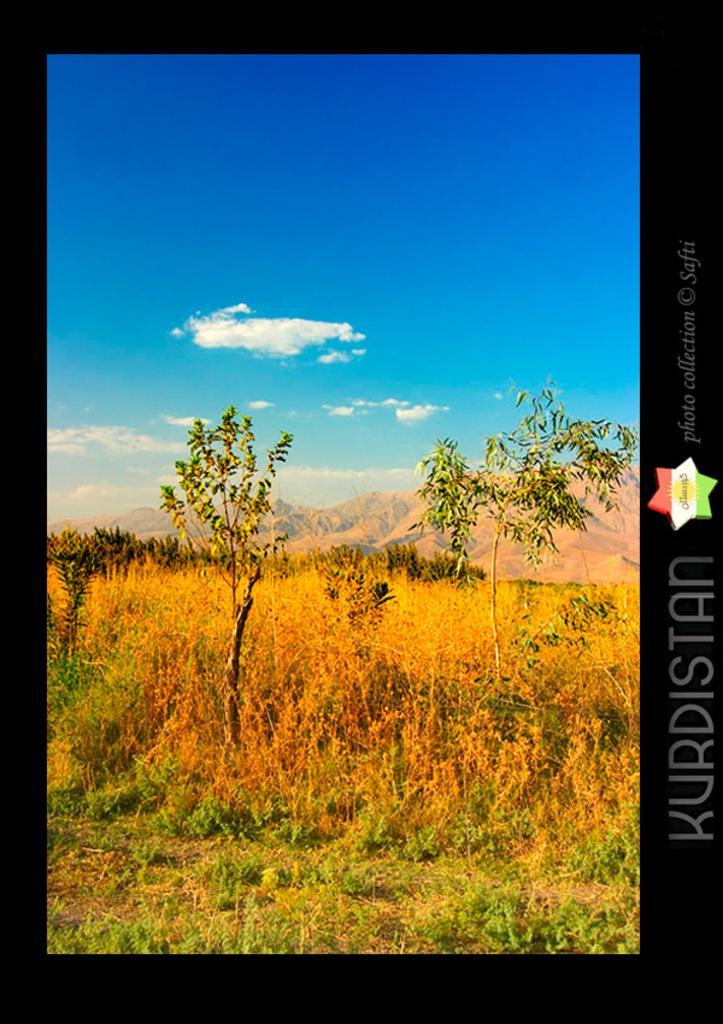Could you give a brief overview of what you see in this image? In this image I can see plants and there are mountains at the back. There are black boundaries. 